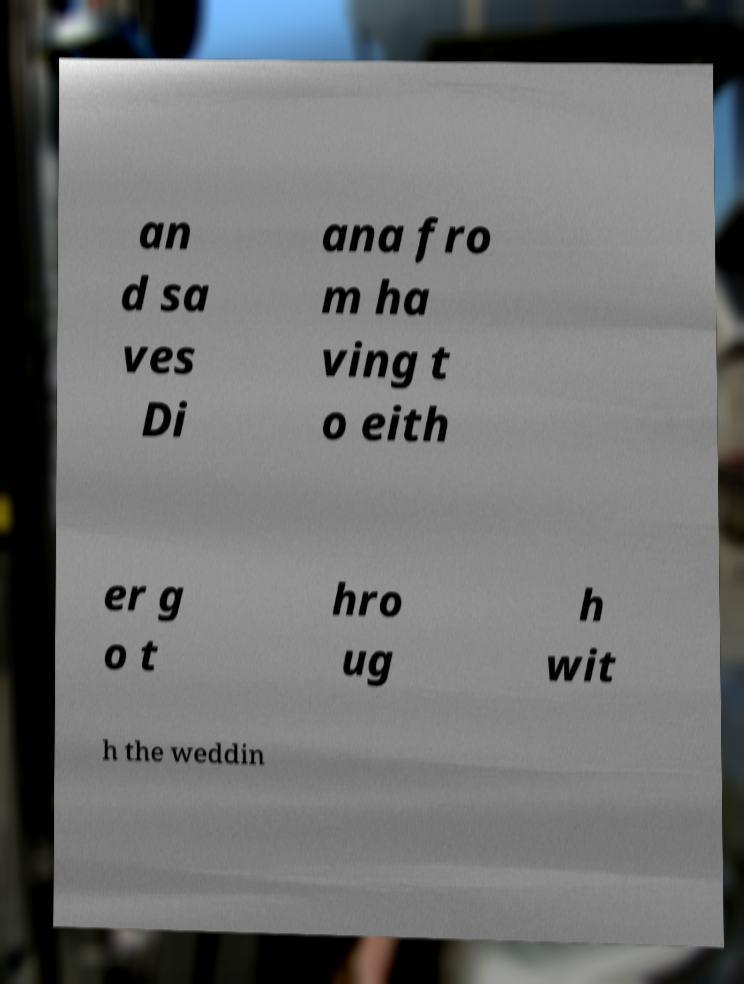What messages or text are displayed in this image? I need them in a readable, typed format. an d sa ves Di ana fro m ha ving t o eith er g o t hro ug h wit h the weddin 